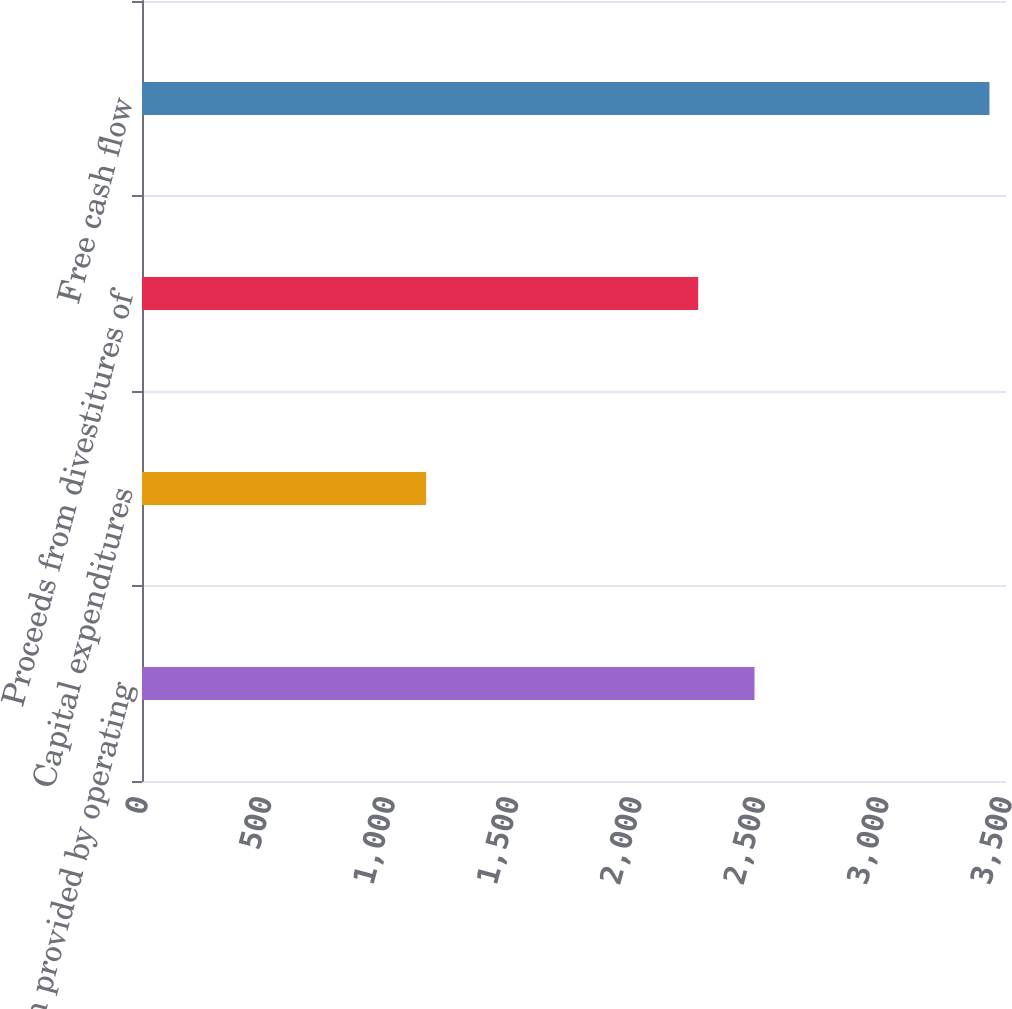Convert chart. <chart><loc_0><loc_0><loc_500><loc_500><bar_chart><fcel>Net cash provided by operating<fcel>Capital expenditures<fcel>Proceeds from divestitures of<fcel>Free cash flow<nl><fcel>2481.2<fcel>1151<fcel>2253<fcel>3433<nl></chart> 